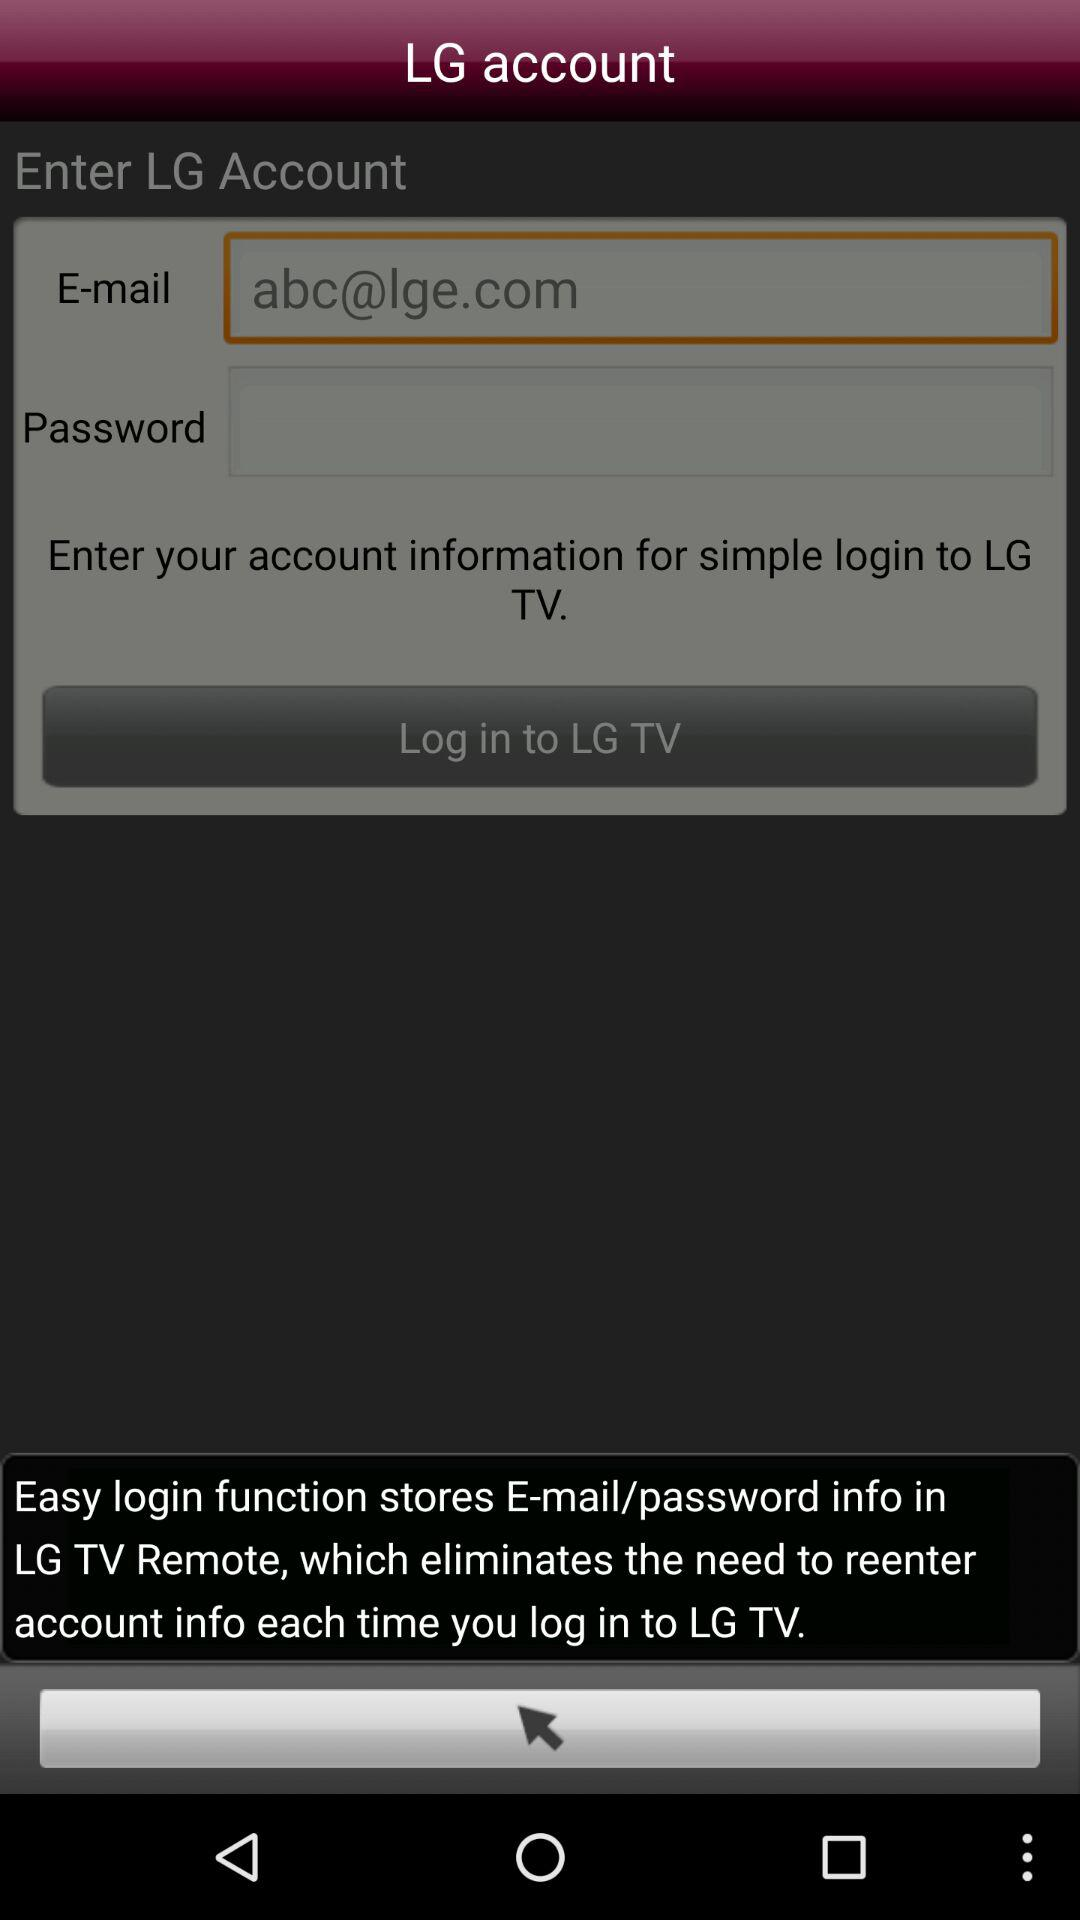What is the application name? The application name is "LG TV". 